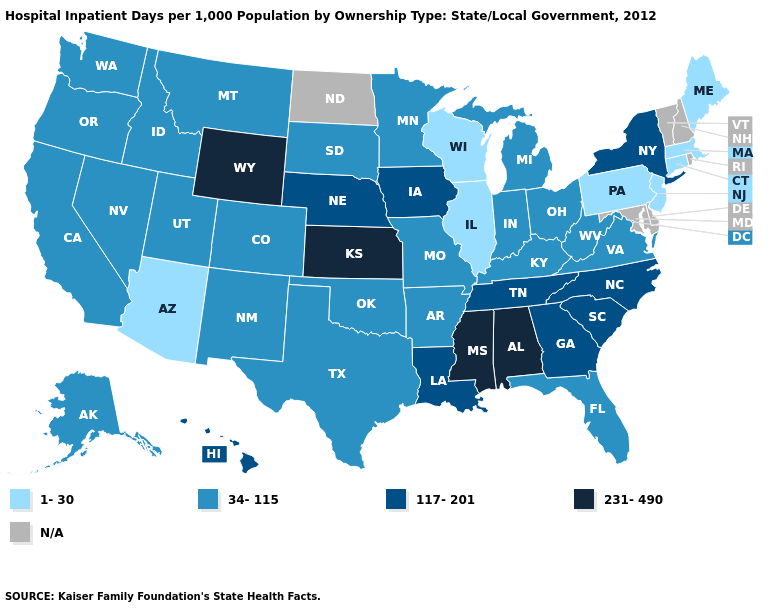What is the value of Oklahoma?
Keep it brief. 34-115. Does Kentucky have the highest value in the USA?
Concise answer only. No. What is the value of Kansas?
Concise answer only. 231-490. Does New York have the highest value in the Northeast?
Be succinct. Yes. What is the value of Connecticut?
Quick response, please. 1-30. What is the highest value in the USA?
Give a very brief answer. 231-490. What is the value of Florida?
Quick response, please. 34-115. Is the legend a continuous bar?
Concise answer only. No. Which states hav the highest value in the MidWest?
Short answer required. Kansas. Does Mississippi have the highest value in the USA?
Short answer required. Yes. Name the states that have a value in the range 117-201?
Keep it brief. Georgia, Hawaii, Iowa, Louisiana, Nebraska, New York, North Carolina, South Carolina, Tennessee. What is the lowest value in the USA?
Concise answer only. 1-30. Name the states that have a value in the range 1-30?
Be succinct. Arizona, Connecticut, Illinois, Maine, Massachusetts, New Jersey, Pennsylvania, Wisconsin. Among the states that border Wyoming , which have the lowest value?
Write a very short answer. Colorado, Idaho, Montana, South Dakota, Utah. 